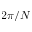Convert formula to latex. <formula><loc_0><loc_0><loc_500><loc_500>2 \pi / N</formula> 